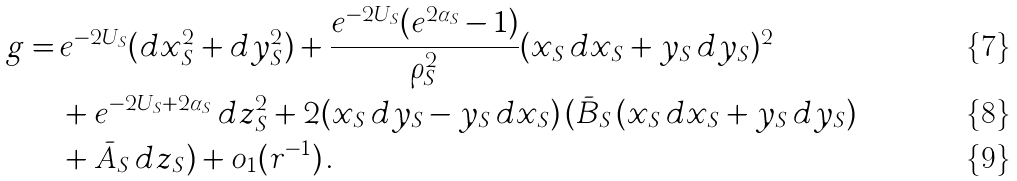Convert formula to latex. <formula><loc_0><loc_0><loc_500><loc_500>g = \, & e ^ { - 2 U _ { S } } ( d x _ { S } ^ { 2 } + d y _ { S } ^ { 2 } ) + \frac { e ^ { - 2 U _ { S } } ( e ^ { 2 \alpha _ { S } } - 1 ) } { \rho _ { S } ^ { 2 } } ( x _ { S } \, d x _ { S } + y _ { S } \, d y _ { S } ) ^ { 2 } \\ & + e ^ { - 2 U _ { S } + 2 \alpha _ { S } } \, d z _ { S } ^ { 2 } + 2 ( x _ { S } \, d y _ { S } - y _ { S } \, d x _ { S } ) \, ( \bar { B } _ { S } \, ( x _ { S } \, d x _ { S } + y _ { S } \, d y _ { S } ) \\ & + \bar { A } _ { S } \, d z _ { S } ) + o _ { 1 } ( r ^ { - 1 } ) \, .</formula> 